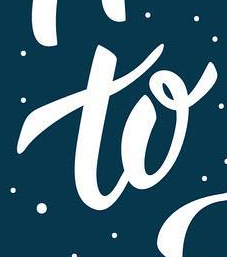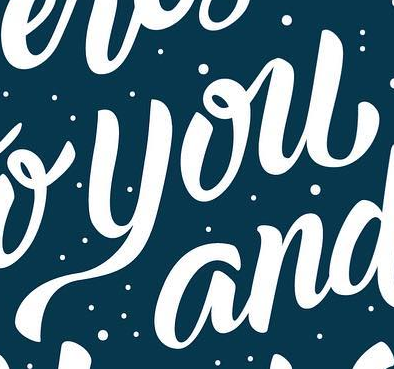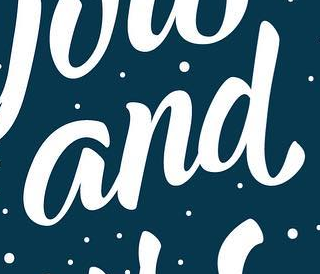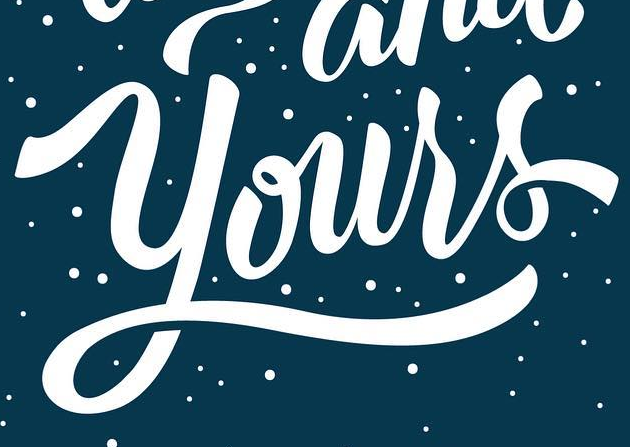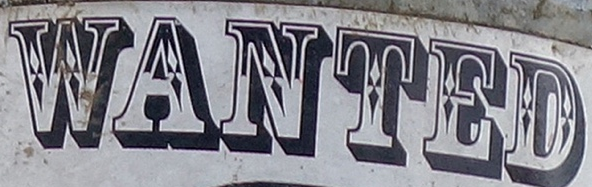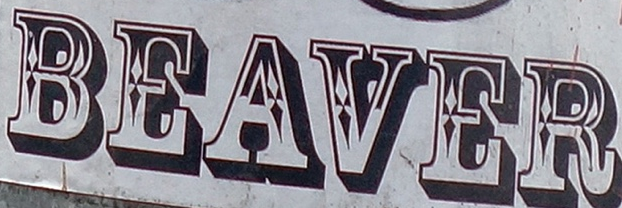What words can you see in these images in sequence, separated by a semicolon? to; you; and; Yours; WANTED; BEAVER 